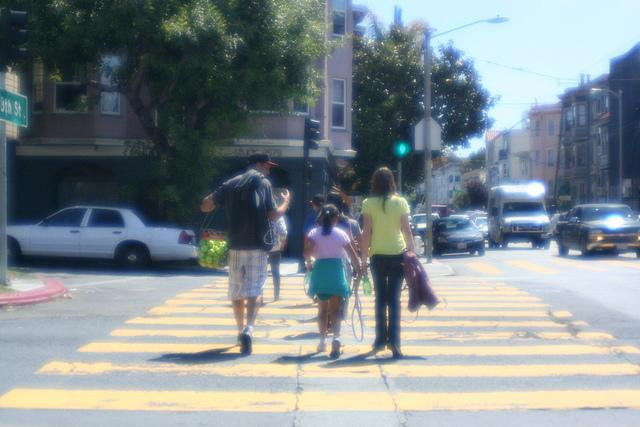How many people can be seen?

Choices:
A) three
B) four
C) six
D) five six 